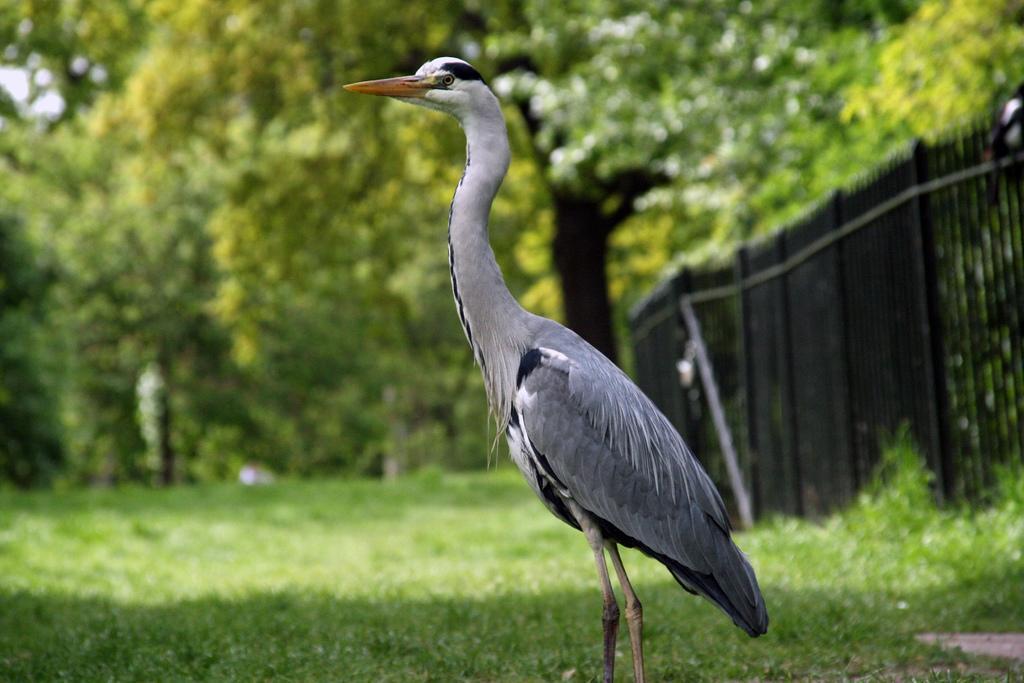Can you describe this image briefly? In this image, we can see some trees and grass. There is a crane in the middle of the image. There is a fence on the right side of the image. 